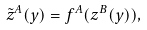Convert formula to latex. <formula><loc_0><loc_0><loc_500><loc_500>\tilde { z } ^ { A } ( y ) = f ^ { A } ( z ^ { B } ( y ) ) ,</formula> 